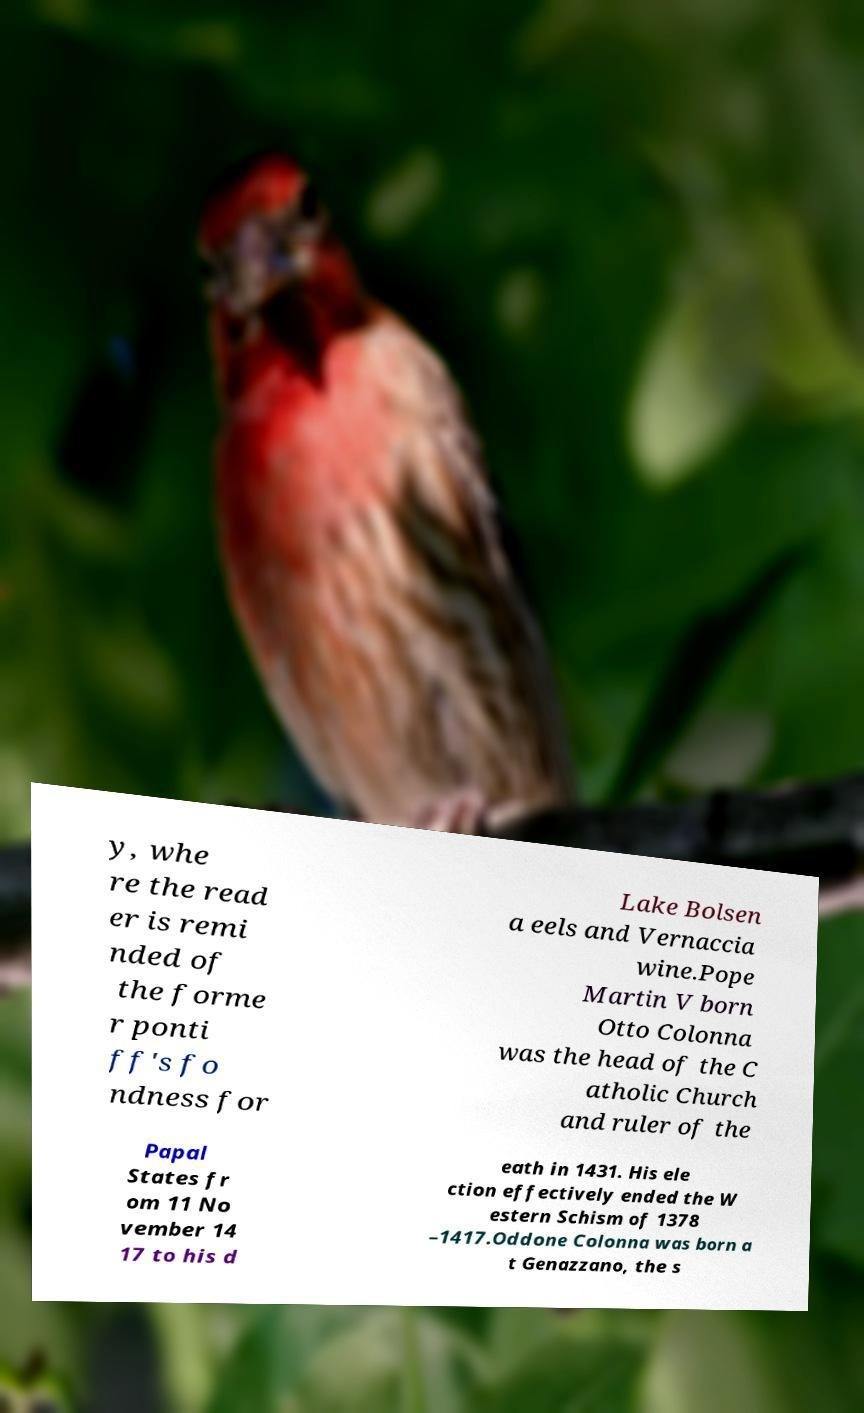For documentation purposes, I need the text within this image transcribed. Could you provide that? y, whe re the read er is remi nded of the forme r ponti ff's fo ndness for Lake Bolsen a eels and Vernaccia wine.Pope Martin V born Otto Colonna was the head of the C atholic Church and ruler of the Papal States fr om 11 No vember 14 17 to his d eath in 1431. His ele ction effectively ended the W estern Schism of 1378 –1417.Oddone Colonna was born a t Genazzano, the s 